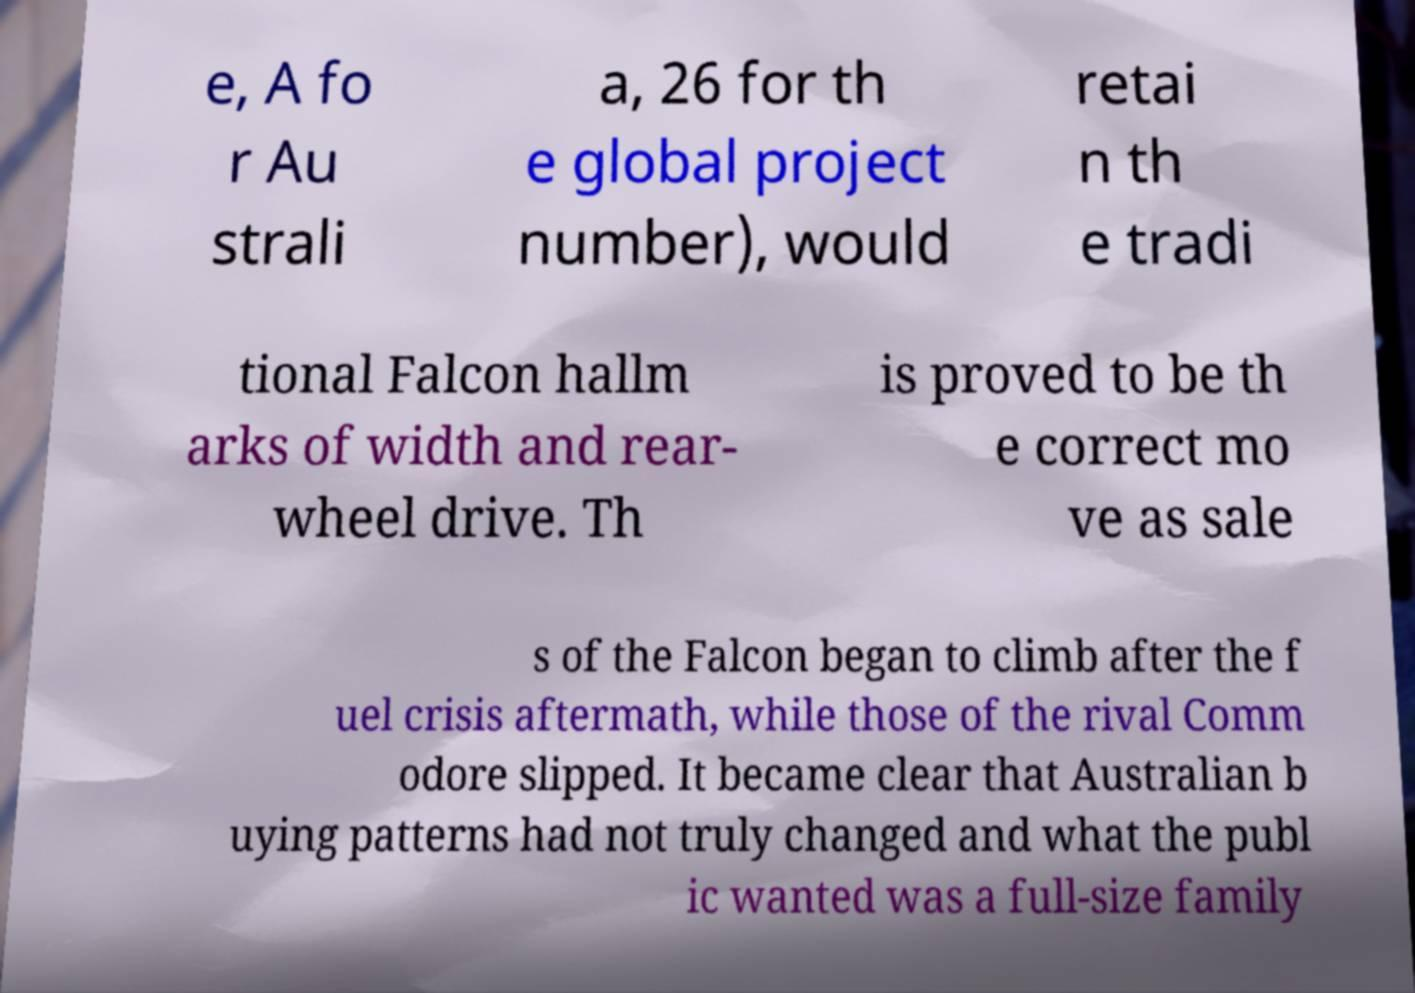What messages or text are displayed in this image? I need them in a readable, typed format. e, A fo r Au strali a, 26 for th e global project number), would retai n th e tradi tional Falcon hallm arks of width and rear- wheel drive. Th is proved to be th e correct mo ve as sale s of the Falcon began to climb after the f uel crisis aftermath, while those of the rival Comm odore slipped. It became clear that Australian b uying patterns had not truly changed and what the publ ic wanted was a full-size family 